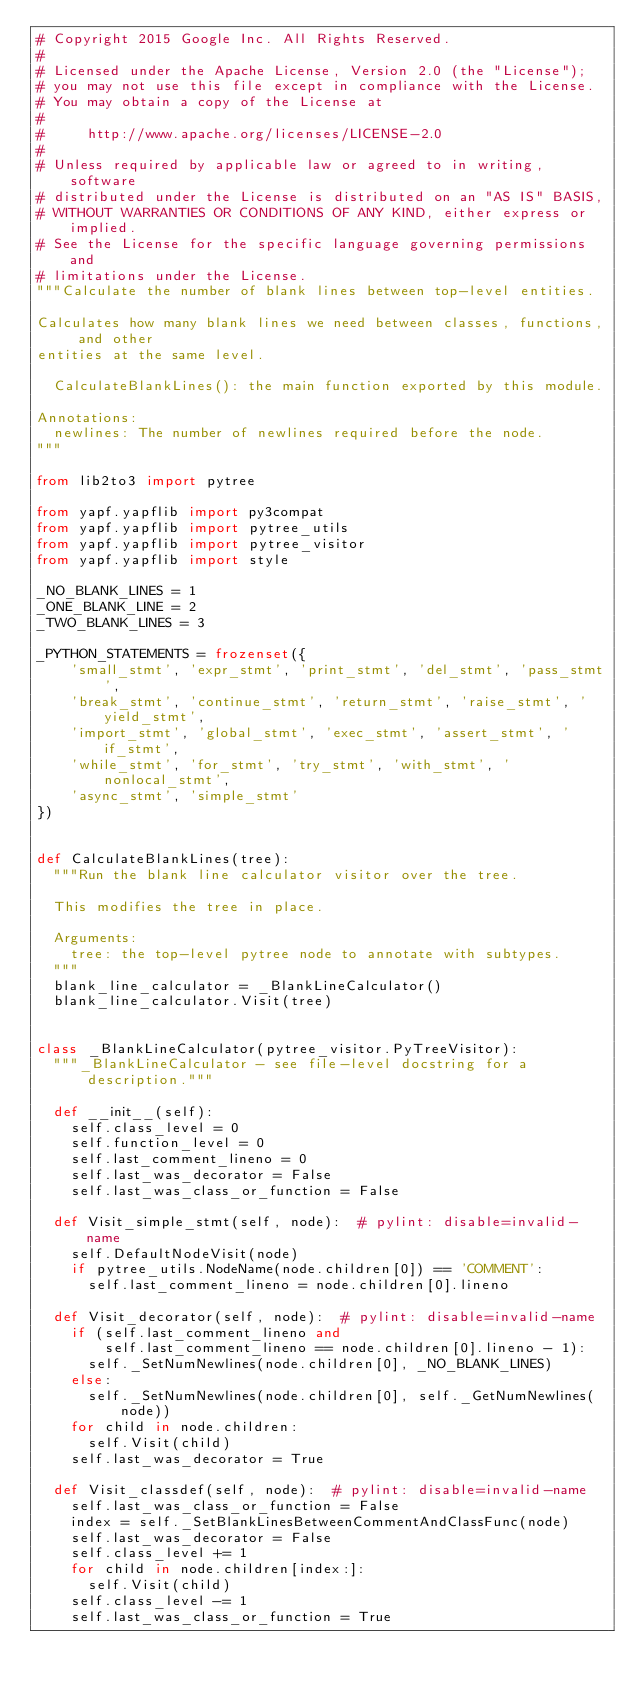<code> <loc_0><loc_0><loc_500><loc_500><_Python_># Copyright 2015 Google Inc. All Rights Reserved.
#
# Licensed under the Apache License, Version 2.0 (the "License");
# you may not use this file except in compliance with the License.
# You may obtain a copy of the License at
#
#     http://www.apache.org/licenses/LICENSE-2.0
#
# Unless required by applicable law or agreed to in writing, software
# distributed under the License is distributed on an "AS IS" BASIS,
# WITHOUT WARRANTIES OR CONDITIONS OF ANY KIND, either express or implied.
# See the License for the specific language governing permissions and
# limitations under the License.
"""Calculate the number of blank lines between top-level entities.

Calculates how many blank lines we need between classes, functions, and other
entities at the same level.

  CalculateBlankLines(): the main function exported by this module.

Annotations:
  newlines: The number of newlines required before the node.
"""

from lib2to3 import pytree

from yapf.yapflib import py3compat
from yapf.yapflib import pytree_utils
from yapf.yapflib import pytree_visitor
from yapf.yapflib import style

_NO_BLANK_LINES = 1
_ONE_BLANK_LINE = 2
_TWO_BLANK_LINES = 3

_PYTHON_STATEMENTS = frozenset({
    'small_stmt', 'expr_stmt', 'print_stmt', 'del_stmt', 'pass_stmt',
    'break_stmt', 'continue_stmt', 'return_stmt', 'raise_stmt', 'yield_stmt',
    'import_stmt', 'global_stmt', 'exec_stmt', 'assert_stmt', 'if_stmt',
    'while_stmt', 'for_stmt', 'try_stmt', 'with_stmt', 'nonlocal_stmt',
    'async_stmt', 'simple_stmt'
})


def CalculateBlankLines(tree):
  """Run the blank line calculator visitor over the tree.

  This modifies the tree in place.

  Arguments:
    tree: the top-level pytree node to annotate with subtypes.
  """
  blank_line_calculator = _BlankLineCalculator()
  blank_line_calculator.Visit(tree)


class _BlankLineCalculator(pytree_visitor.PyTreeVisitor):
  """_BlankLineCalculator - see file-level docstring for a description."""

  def __init__(self):
    self.class_level = 0
    self.function_level = 0
    self.last_comment_lineno = 0
    self.last_was_decorator = False
    self.last_was_class_or_function = False

  def Visit_simple_stmt(self, node):  # pylint: disable=invalid-name
    self.DefaultNodeVisit(node)
    if pytree_utils.NodeName(node.children[0]) == 'COMMENT':
      self.last_comment_lineno = node.children[0].lineno

  def Visit_decorator(self, node):  # pylint: disable=invalid-name
    if (self.last_comment_lineno and
        self.last_comment_lineno == node.children[0].lineno - 1):
      self._SetNumNewlines(node.children[0], _NO_BLANK_LINES)
    else:
      self._SetNumNewlines(node.children[0], self._GetNumNewlines(node))
    for child in node.children:
      self.Visit(child)
    self.last_was_decorator = True

  def Visit_classdef(self, node):  # pylint: disable=invalid-name
    self.last_was_class_or_function = False
    index = self._SetBlankLinesBetweenCommentAndClassFunc(node)
    self.last_was_decorator = False
    self.class_level += 1
    for child in node.children[index:]:
      self.Visit(child)
    self.class_level -= 1
    self.last_was_class_or_function = True
</code> 